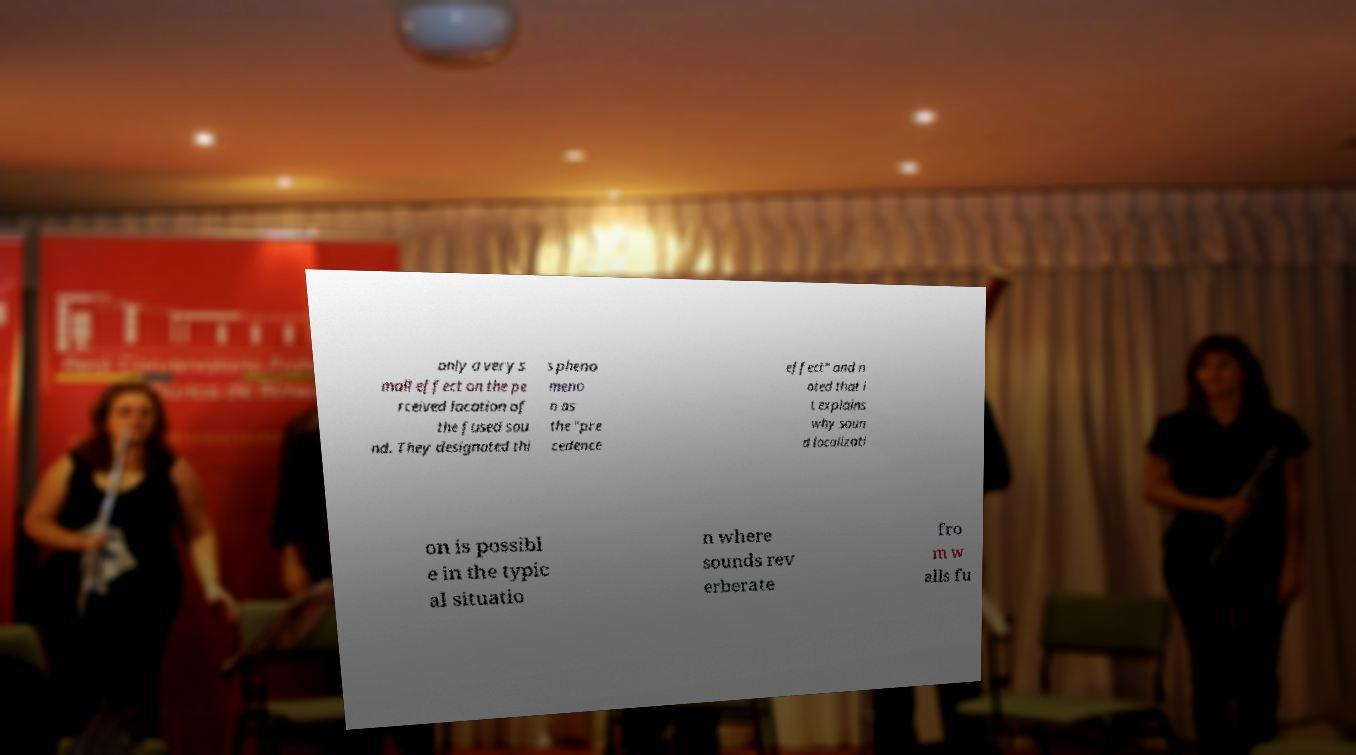There's text embedded in this image that I need extracted. Can you transcribe it verbatim? only a very s mall effect on the pe rceived location of the fused sou nd. They designated thi s pheno meno n as the "pre cedence effect" and n oted that i t explains why soun d localizati on is possibl e in the typic al situatio n where sounds rev erberate fro m w alls fu 